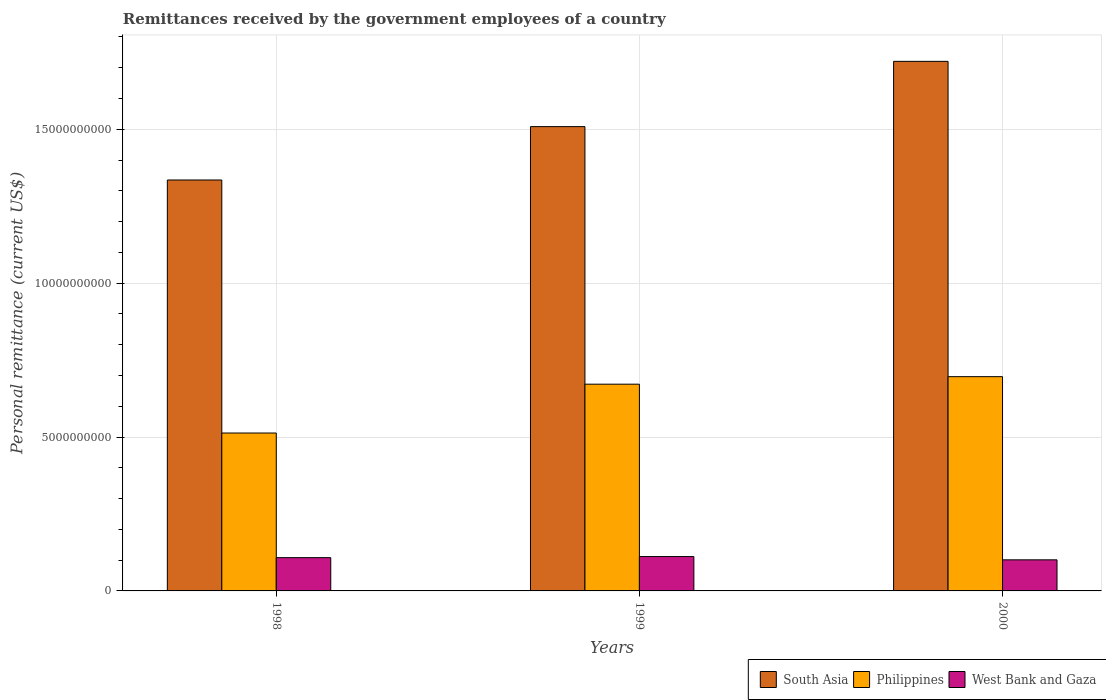How many groups of bars are there?
Provide a succinct answer. 3. Are the number of bars per tick equal to the number of legend labels?
Give a very brief answer. Yes. Are the number of bars on each tick of the X-axis equal?
Give a very brief answer. Yes. How many bars are there on the 2nd tick from the right?
Give a very brief answer. 3. What is the remittances received by the government employees in West Bank and Gaza in 1998?
Your answer should be compact. 1.08e+09. Across all years, what is the maximum remittances received by the government employees in West Bank and Gaza?
Give a very brief answer. 1.12e+09. Across all years, what is the minimum remittances received by the government employees in West Bank and Gaza?
Keep it short and to the point. 1.01e+09. What is the total remittances received by the government employees in South Asia in the graph?
Your response must be concise. 4.56e+1. What is the difference between the remittances received by the government employees in South Asia in 1999 and that in 2000?
Offer a very short reply. -2.12e+09. What is the difference between the remittances received by the government employees in Philippines in 1998 and the remittances received by the government employees in South Asia in 1999?
Provide a short and direct response. -9.96e+09. What is the average remittances received by the government employees in South Asia per year?
Make the answer very short. 1.52e+1. In the year 1999, what is the difference between the remittances received by the government employees in Philippines and remittances received by the government employees in South Asia?
Make the answer very short. -8.37e+09. What is the ratio of the remittances received by the government employees in South Asia in 1998 to that in 2000?
Ensure brevity in your answer.  0.78. Is the remittances received by the government employees in South Asia in 1998 less than that in 2000?
Make the answer very short. Yes. Is the difference between the remittances received by the government employees in Philippines in 1999 and 2000 greater than the difference between the remittances received by the government employees in South Asia in 1999 and 2000?
Make the answer very short. Yes. What is the difference between the highest and the second highest remittances received by the government employees in South Asia?
Your response must be concise. 2.12e+09. What is the difference between the highest and the lowest remittances received by the government employees in West Bank and Gaza?
Your answer should be very brief. 1.06e+08. In how many years, is the remittances received by the government employees in West Bank and Gaza greater than the average remittances received by the government employees in West Bank and Gaza taken over all years?
Keep it short and to the point. 2. What does the 1st bar from the left in 2000 represents?
Provide a short and direct response. South Asia. Is it the case that in every year, the sum of the remittances received by the government employees in Philippines and remittances received by the government employees in South Asia is greater than the remittances received by the government employees in West Bank and Gaza?
Ensure brevity in your answer.  Yes. How many years are there in the graph?
Offer a terse response. 3. Are the values on the major ticks of Y-axis written in scientific E-notation?
Your answer should be compact. No. How are the legend labels stacked?
Keep it short and to the point. Horizontal. What is the title of the graph?
Provide a succinct answer. Remittances received by the government employees of a country. Does "Middle East & North Africa (developing only)" appear as one of the legend labels in the graph?
Make the answer very short. No. What is the label or title of the X-axis?
Offer a very short reply. Years. What is the label or title of the Y-axis?
Your answer should be very brief. Personal remittance (current US$). What is the Personal remittance (current US$) of South Asia in 1998?
Offer a terse response. 1.34e+1. What is the Personal remittance (current US$) of Philippines in 1998?
Provide a short and direct response. 5.13e+09. What is the Personal remittance (current US$) of West Bank and Gaza in 1998?
Make the answer very short. 1.08e+09. What is the Personal remittance (current US$) of South Asia in 1999?
Your answer should be very brief. 1.51e+1. What is the Personal remittance (current US$) of Philippines in 1999?
Offer a very short reply. 6.72e+09. What is the Personal remittance (current US$) in West Bank and Gaza in 1999?
Your response must be concise. 1.12e+09. What is the Personal remittance (current US$) of South Asia in 2000?
Your answer should be very brief. 1.72e+1. What is the Personal remittance (current US$) in Philippines in 2000?
Offer a very short reply. 6.96e+09. What is the Personal remittance (current US$) of West Bank and Gaza in 2000?
Give a very brief answer. 1.01e+09. Across all years, what is the maximum Personal remittance (current US$) of South Asia?
Your answer should be very brief. 1.72e+1. Across all years, what is the maximum Personal remittance (current US$) of Philippines?
Ensure brevity in your answer.  6.96e+09. Across all years, what is the maximum Personal remittance (current US$) of West Bank and Gaza?
Offer a very short reply. 1.12e+09. Across all years, what is the minimum Personal remittance (current US$) of South Asia?
Make the answer very short. 1.34e+1. Across all years, what is the minimum Personal remittance (current US$) of Philippines?
Keep it short and to the point. 5.13e+09. Across all years, what is the minimum Personal remittance (current US$) in West Bank and Gaza?
Offer a very short reply. 1.01e+09. What is the total Personal remittance (current US$) in South Asia in the graph?
Give a very brief answer. 4.56e+1. What is the total Personal remittance (current US$) in Philippines in the graph?
Keep it short and to the point. 1.88e+1. What is the total Personal remittance (current US$) of West Bank and Gaza in the graph?
Your answer should be compact. 3.21e+09. What is the difference between the Personal remittance (current US$) of South Asia in 1998 and that in 1999?
Your response must be concise. -1.73e+09. What is the difference between the Personal remittance (current US$) in Philippines in 1998 and that in 1999?
Keep it short and to the point. -1.59e+09. What is the difference between the Personal remittance (current US$) in West Bank and Gaza in 1998 and that in 1999?
Offer a very short reply. -3.50e+07. What is the difference between the Personal remittance (current US$) in South Asia in 1998 and that in 2000?
Provide a short and direct response. -3.85e+09. What is the difference between the Personal remittance (current US$) of Philippines in 1998 and that in 2000?
Keep it short and to the point. -1.83e+09. What is the difference between the Personal remittance (current US$) in West Bank and Gaza in 1998 and that in 2000?
Offer a terse response. 7.11e+07. What is the difference between the Personal remittance (current US$) in South Asia in 1999 and that in 2000?
Give a very brief answer. -2.12e+09. What is the difference between the Personal remittance (current US$) of Philippines in 1999 and that in 2000?
Offer a terse response. -2.44e+08. What is the difference between the Personal remittance (current US$) of West Bank and Gaza in 1999 and that in 2000?
Your response must be concise. 1.06e+08. What is the difference between the Personal remittance (current US$) of South Asia in 1998 and the Personal remittance (current US$) of Philippines in 1999?
Make the answer very short. 6.63e+09. What is the difference between the Personal remittance (current US$) in South Asia in 1998 and the Personal remittance (current US$) in West Bank and Gaza in 1999?
Give a very brief answer. 1.22e+1. What is the difference between the Personal remittance (current US$) in Philippines in 1998 and the Personal remittance (current US$) in West Bank and Gaza in 1999?
Provide a succinct answer. 4.01e+09. What is the difference between the Personal remittance (current US$) in South Asia in 1998 and the Personal remittance (current US$) in Philippines in 2000?
Ensure brevity in your answer.  6.39e+09. What is the difference between the Personal remittance (current US$) in South Asia in 1998 and the Personal remittance (current US$) in West Bank and Gaza in 2000?
Provide a short and direct response. 1.23e+1. What is the difference between the Personal remittance (current US$) in Philippines in 1998 and the Personal remittance (current US$) in West Bank and Gaza in 2000?
Offer a very short reply. 4.12e+09. What is the difference between the Personal remittance (current US$) of South Asia in 1999 and the Personal remittance (current US$) of Philippines in 2000?
Provide a short and direct response. 8.12e+09. What is the difference between the Personal remittance (current US$) of South Asia in 1999 and the Personal remittance (current US$) of West Bank and Gaza in 2000?
Offer a terse response. 1.41e+1. What is the difference between the Personal remittance (current US$) of Philippines in 1999 and the Personal remittance (current US$) of West Bank and Gaza in 2000?
Ensure brevity in your answer.  5.71e+09. What is the average Personal remittance (current US$) in South Asia per year?
Provide a succinct answer. 1.52e+1. What is the average Personal remittance (current US$) of Philippines per year?
Keep it short and to the point. 6.27e+09. What is the average Personal remittance (current US$) of West Bank and Gaza per year?
Your answer should be very brief. 1.07e+09. In the year 1998, what is the difference between the Personal remittance (current US$) of South Asia and Personal remittance (current US$) of Philippines?
Your response must be concise. 8.22e+09. In the year 1998, what is the difference between the Personal remittance (current US$) of South Asia and Personal remittance (current US$) of West Bank and Gaza?
Offer a very short reply. 1.23e+1. In the year 1998, what is the difference between the Personal remittance (current US$) in Philippines and Personal remittance (current US$) in West Bank and Gaza?
Your response must be concise. 4.05e+09. In the year 1999, what is the difference between the Personal remittance (current US$) in South Asia and Personal remittance (current US$) in Philippines?
Keep it short and to the point. 8.37e+09. In the year 1999, what is the difference between the Personal remittance (current US$) of South Asia and Personal remittance (current US$) of West Bank and Gaza?
Provide a short and direct response. 1.40e+1. In the year 1999, what is the difference between the Personal remittance (current US$) in Philippines and Personal remittance (current US$) in West Bank and Gaza?
Offer a terse response. 5.60e+09. In the year 2000, what is the difference between the Personal remittance (current US$) of South Asia and Personal remittance (current US$) of Philippines?
Provide a short and direct response. 1.02e+1. In the year 2000, what is the difference between the Personal remittance (current US$) of South Asia and Personal remittance (current US$) of West Bank and Gaza?
Offer a terse response. 1.62e+1. In the year 2000, what is the difference between the Personal remittance (current US$) of Philippines and Personal remittance (current US$) of West Bank and Gaza?
Ensure brevity in your answer.  5.95e+09. What is the ratio of the Personal remittance (current US$) of South Asia in 1998 to that in 1999?
Keep it short and to the point. 0.89. What is the ratio of the Personal remittance (current US$) of Philippines in 1998 to that in 1999?
Make the answer very short. 0.76. What is the ratio of the Personal remittance (current US$) of West Bank and Gaza in 1998 to that in 1999?
Offer a terse response. 0.97. What is the ratio of the Personal remittance (current US$) of South Asia in 1998 to that in 2000?
Provide a succinct answer. 0.78. What is the ratio of the Personal remittance (current US$) in Philippines in 1998 to that in 2000?
Your answer should be compact. 0.74. What is the ratio of the Personal remittance (current US$) in West Bank and Gaza in 1998 to that in 2000?
Keep it short and to the point. 1.07. What is the ratio of the Personal remittance (current US$) of South Asia in 1999 to that in 2000?
Offer a terse response. 0.88. What is the ratio of the Personal remittance (current US$) of Philippines in 1999 to that in 2000?
Give a very brief answer. 0.96. What is the ratio of the Personal remittance (current US$) of West Bank and Gaza in 1999 to that in 2000?
Your response must be concise. 1.1. What is the difference between the highest and the second highest Personal remittance (current US$) of South Asia?
Provide a short and direct response. 2.12e+09. What is the difference between the highest and the second highest Personal remittance (current US$) in Philippines?
Offer a very short reply. 2.44e+08. What is the difference between the highest and the second highest Personal remittance (current US$) in West Bank and Gaza?
Your answer should be compact. 3.50e+07. What is the difference between the highest and the lowest Personal remittance (current US$) of South Asia?
Your answer should be compact. 3.85e+09. What is the difference between the highest and the lowest Personal remittance (current US$) in Philippines?
Provide a short and direct response. 1.83e+09. What is the difference between the highest and the lowest Personal remittance (current US$) in West Bank and Gaza?
Offer a very short reply. 1.06e+08. 